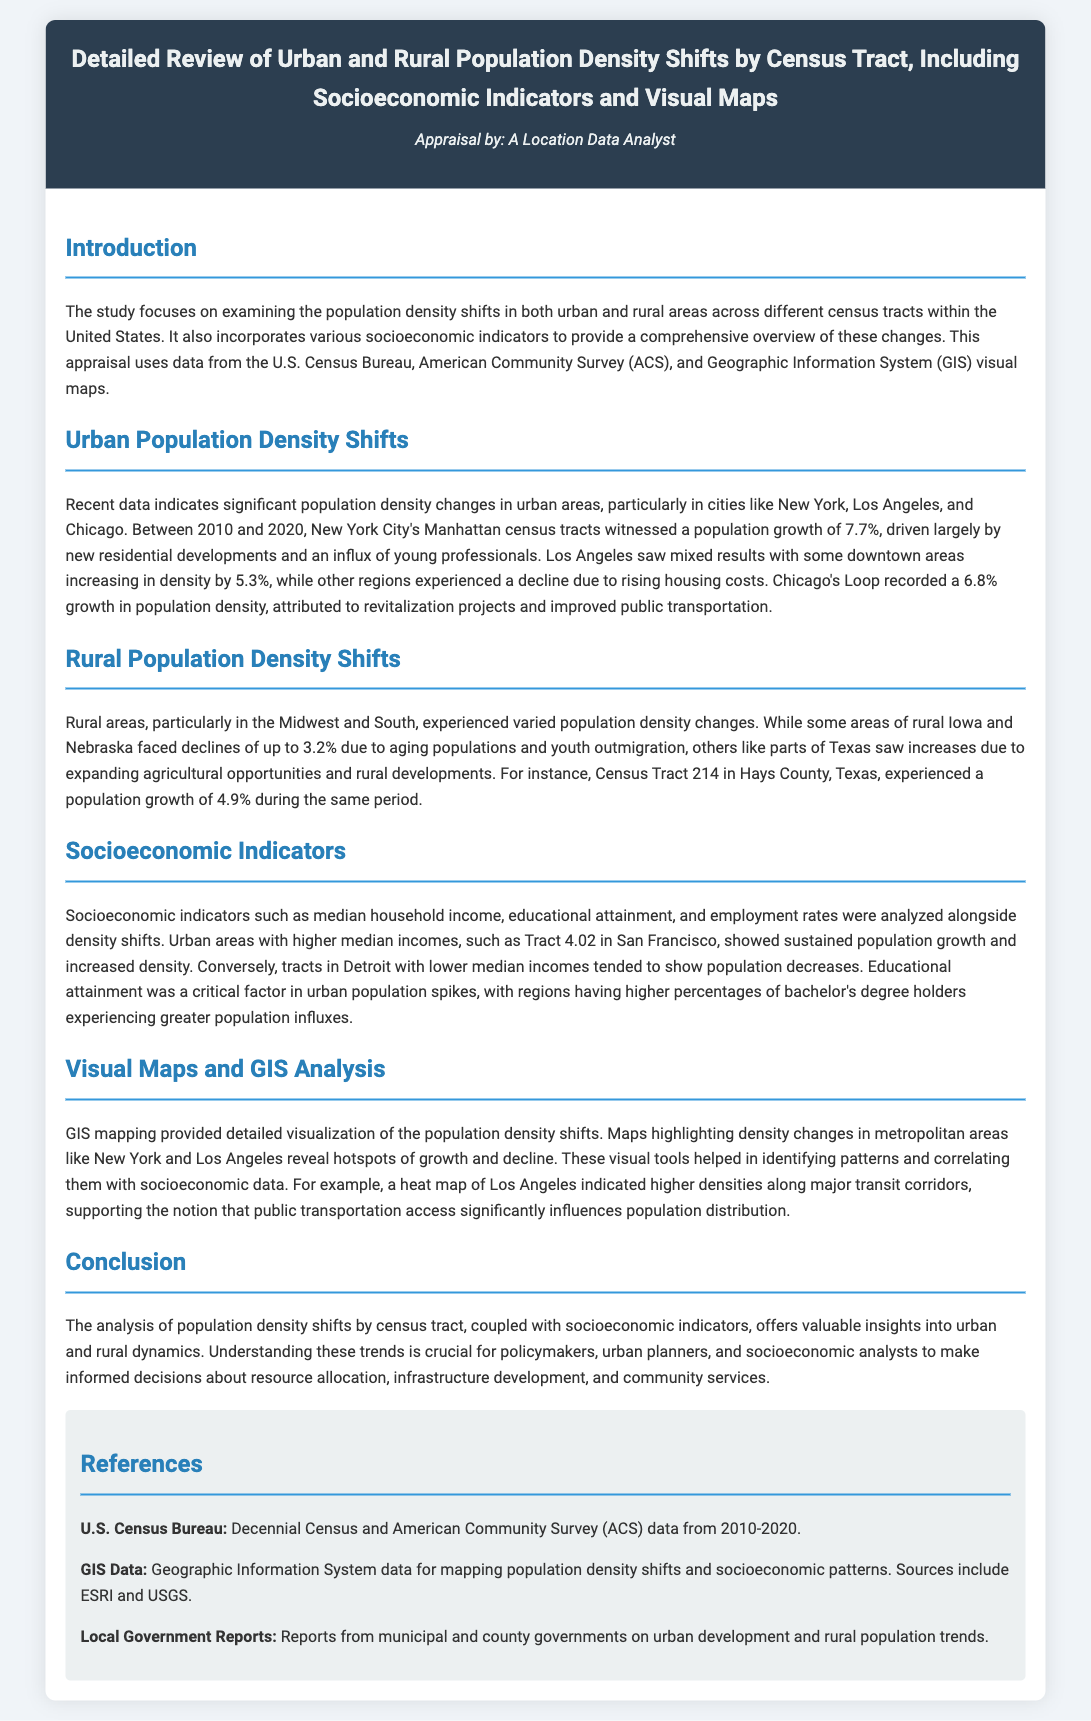what was the population growth percentage in Manhattan? The document states that Manhattan witnessed a population growth of 7.7%.
Answer: 7.7% which cities were highlighted for urban population density shifts? The cities emphasized are New York, Los Angeles, and Chicago.
Answer: New York, Los Angeles, and Chicago what is the population density change percentage in rural Iowa and Nebraska? The document mentions some areas faced declines of up to 3.2%.
Answer: 3.2% which socioeconomic indicator correlated with greater population influxes? The document highlights educational attainment as a critical factor.
Answer: educational attainment what was the population growth percentage in Hays County, Texas? Census Tract 214 in Hays County experienced a population growth of 4.9%.
Answer: 4.9% what major factor influences population distribution according to the heat map of Los Angeles? The heat map indicates that public transportation access significantly influences population distribution.
Answer: public transportation access what type of mapping was used to visualize the population density shifts? The document states that GIS mapping provided detailed visualization of the shifts.
Answer: GIS mapping which census survey period is discussed in the document? The document mentions analyzing data from the years 2010 to 2020.
Answer: 2010 to 2020 what is the document's primary focus? The primary focus is examining population density shifts and socioeconomic indicators.
Answer: population density shifts and socioeconomic indicators 